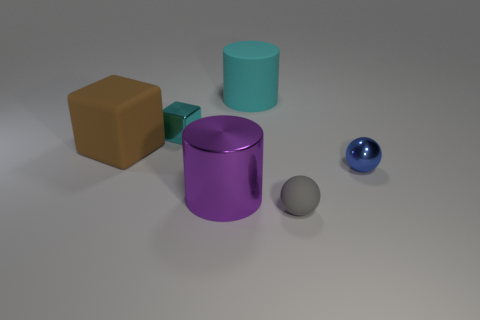Are there any large things of the same color as the metallic block?
Give a very brief answer. Yes. There is a metallic object to the right of the gray object; is its size the same as the purple thing?
Your answer should be compact. No. Is the number of metal objects less than the number of shiny balls?
Your answer should be compact. No. Is there a blue sphere made of the same material as the small cube?
Your answer should be very brief. Yes. The blue thing that is in front of the brown matte cube has what shape?
Your response must be concise. Sphere. There is a cylinder that is behind the small cyan shiny thing; does it have the same color as the metallic block?
Provide a short and direct response. Yes. Are there fewer cubes that are in front of the tiny gray rubber sphere than tiny green metallic things?
Your response must be concise. No. The cylinder that is the same material as the tiny blue thing is what color?
Give a very brief answer. Purple. There is a brown matte object that is to the left of the tiny cyan object; what is its size?
Make the answer very short. Large. Are the cyan block and the tiny blue sphere made of the same material?
Provide a succinct answer. Yes. 